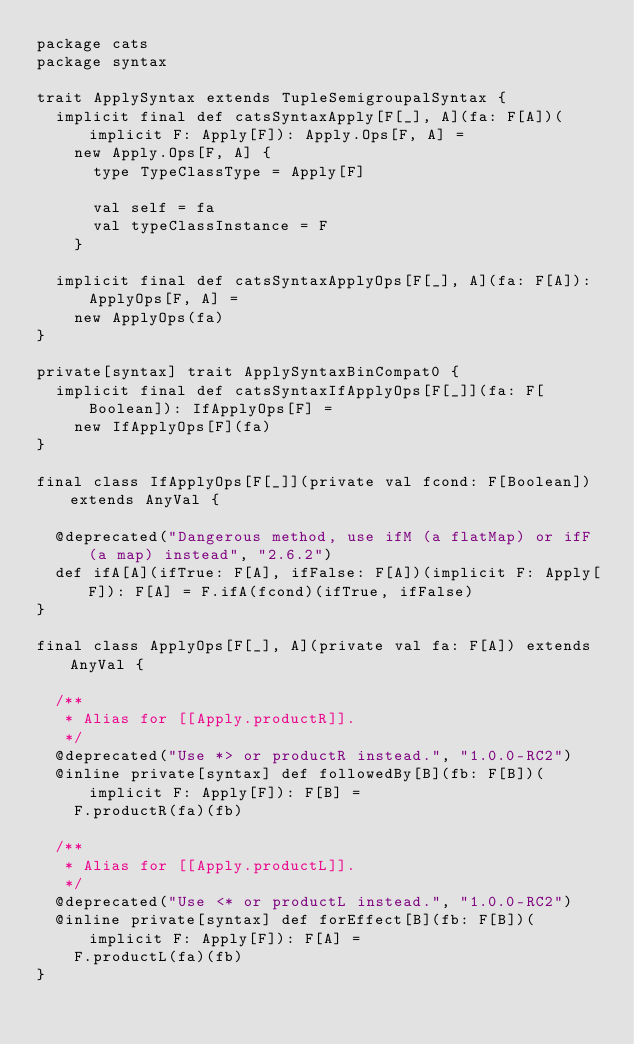<code> <loc_0><loc_0><loc_500><loc_500><_Scala_>package cats
package syntax

trait ApplySyntax extends TupleSemigroupalSyntax {
  implicit final def catsSyntaxApply[F[_], A](fa: F[A])(implicit F: Apply[F]): Apply.Ops[F, A] =
    new Apply.Ops[F, A] {
      type TypeClassType = Apply[F]

      val self = fa
      val typeClassInstance = F
    }

  implicit final def catsSyntaxApplyOps[F[_], A](fa: F[A]): ApplyOps[F, A] =
    new ApplyOps(fa)
}

private[syntax] trait ApplySyntaxBinCompat0 {
  implicit final def catsSyntaxIfApplyOps[F[_]](fa: F[Boolean]): IfApplyOps[F] =
    new IfApplyOps[F](fa)
}

final class IfApplyOps[F[_]](private val fcond: F[Boolean]) extends AnyVal {

  @deprecated("Dangerous method, use ifM (a flatMap) or ifF (a map) instead", "2.6.2")
  def ifA[A](ifTrue: F[A], ifFalse: F[A])(implicit F: Apply[F]): F[A] = F.ifA(fcond)(ifTrue, ifFalse)
}

final class ApplyOps[F[_], A](private val fa: F[A]) extends AnyVal {

  /**
   * Alias for [[Apply.productR]].
   */
  @deprecated("Use *> or productR instead.", "1.0.0-RC2")
  @inline private[syntax] def followedBy[B](fb: F[B])(implicit F: Apply[F]): F[B] =
    F.productR(fa)(fb)

  /**
   * Alias for [[Apply.productL]].
   */
  @deprecated("Use <* or productL instead.", "1.0.0-RC2")
  @inline private[syntax] def forEffect[B](fb: F[B])(implicit F: Apply[F]): F[A] =
    F.productL(fa)(fb)
}
</code> 